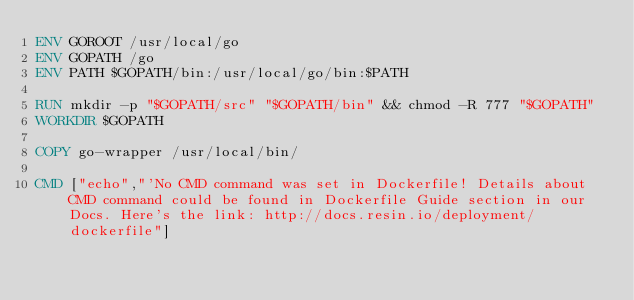<code> <loc_0><loc_0><loc_500><loc_500><_Dockerfile_>ENV GOROOT /usr/local/go
ENV GOPATH /go
ENV PATH $GOPATH/bin:/usr/local/go/bin:$PATH

RUN mkdir -p "$GOPATH/src" "$GOPATH/bin" && chmod -R 777 "$GOPATH"
WORKDIR $GOPATH

COPY go-wrapper /usr/local/bin/

CMD ["echo","'No CMD command was set in Dockerfile! Details about CMD command could be found in Dockerfile Guide section in our Docs. Here's the link: http://docs.resin.io/deployment/dockerfile"]
</code> 